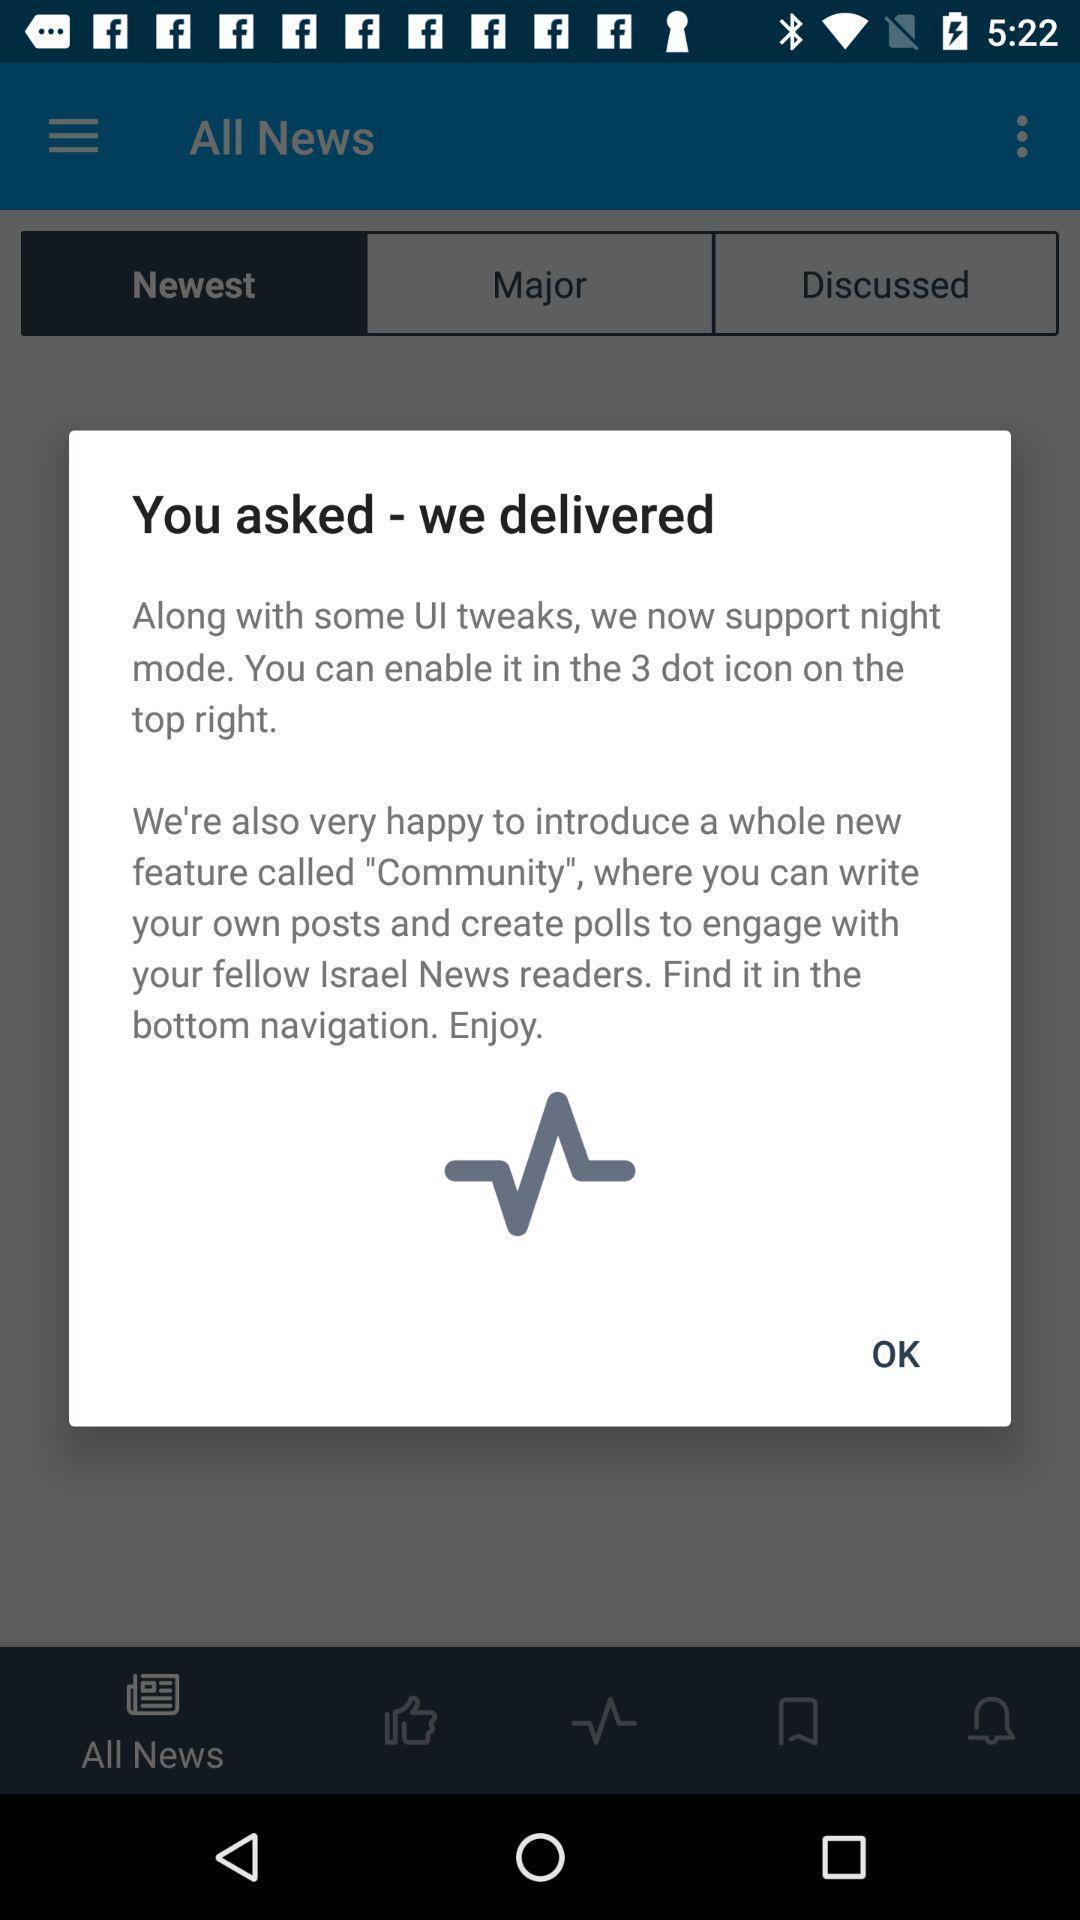Describe the key features of this screenshot. Popup of text regarding expressing gratitude for the customer. 